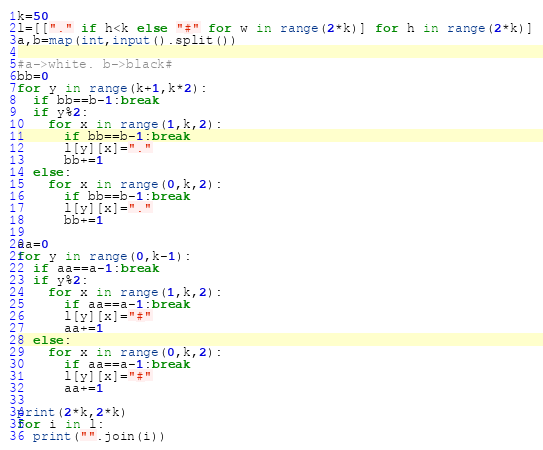<code> <loc_0><loc_0><loc_500><loc_500><_Python_>k=50
l=[["." if h<k else "#" for w in range(2*k)] for h in range(2*k)]
a,b=map(int,input().split())

#a->white. b->black#
bb=0
for y in range(k+1,k*2):
  if bb==b-1:break
  if y%2:
    for x in range(1,k,2):
      if bb==b-1:break
      l[y][x]="."
      bb+=1
  else:
    for x in range(0,k,2):
      if bb==b-1:break
      l[y][x]="."
      bb+=1

aa=0
for y in range(0,k-1):
  if aa==a-1:break
  if y%2:
    for x in range(1,k,2):
      if aa==a-1:break
      l[y][x]="#"
      aa+=1
  else:
    for x in range(0,k,2):
      if aa==a-1:break
      l[y][x]="#"
      aa+=1

print(2*k,2*k)
for i in l:
  print("".join(i))</code> 